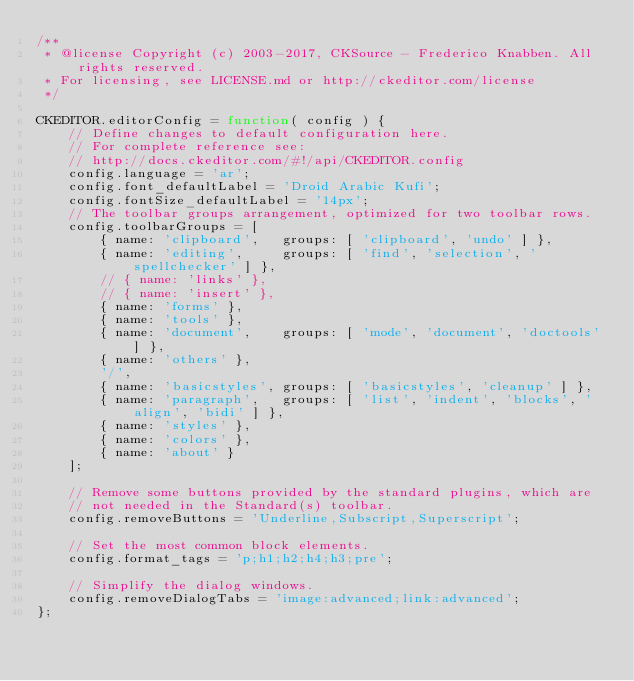Convert code to text. <code><loc_0><loc_0><loc_500><loc_500><_JavaScript_>/**
 * @license Copyright (c) 2003-2017, CKSource - Frederico Knabben. All rights reserved.
 * For licensing, see LICENSE.md or http://ckeditor.com/license
 */

CKEDITOR.editorConfig = function( config ) {
    // Define changes to default configuration here.
    // For complete reference see:
    // http://docs.ckeditor.com/#!/api/CKEDITOR.config
    config.language = 'ar';
    config.font_defaultLabel = 'Droid Arabic Kufi';
    config.fontSize_defaultLabel = '14px';
    // The toolbar groups arrangement, optimized for two toolbar rows.
    config.toolbarGroups = [
        { name: 'clipboard',   groups: [ 'clipboard', 'undo' ] },
        { name: 'editing',     groups: [ 'find', 'selection', 'spellchecker' ] },
        // { name: 'links' },
        // { name: 'insert' },
        { name: 'forms' },
        { name: 'tools' },
        { name: 'document',	   groups: [ 'mode', 'document', 'doctools' ] },
        { name: 'others' },
        '/',
        { name: 'basicstyles', groups: [ 'basicstyles', 'cleanup' ] },
        { name: 'paragraph',   groups: [ 'list', 'indent', 'blocks', 'align', 'bidi' ] },
        { name: 'styles' },
        { name: 'colors' },
        { name: 'about' }
    ];

    // Remove some buttons provided by the standard plugins, which are
    // not needed in the Standard(s) toolbar.
    config.removeButtons = 'Underline,Subscript,Superscript';

    // Set the most common block elements.
    config.format_tags = 'p;h1;h2;h4;h3;pre';

    // Simplify the dialog windows.
    config.removeDialogTabs = 'image:advanced;link:advanced';
};
</code> 